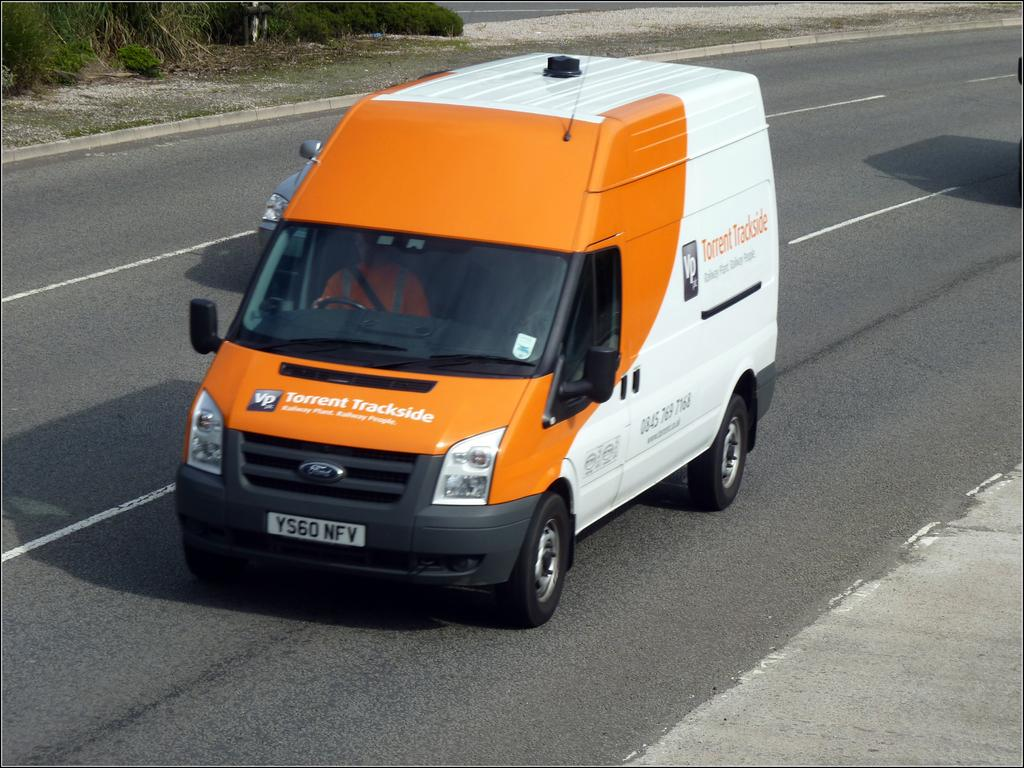<image>
Offer a succinct explanation of the picture presented. A white and orange van with Torrent Trackside written on the hood. 